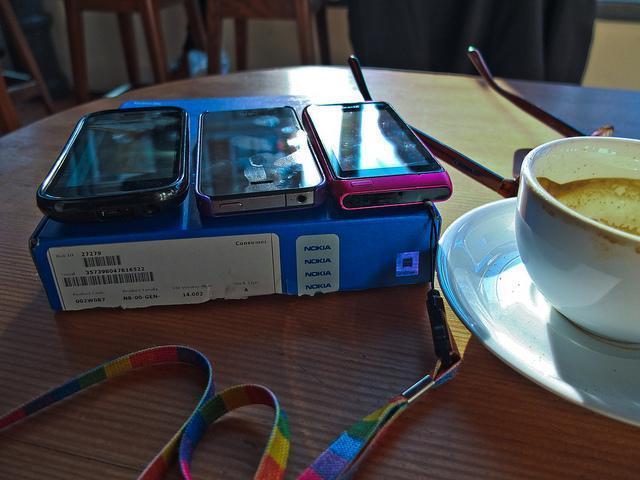How many cell phones are there?
Give a very brief answer. 3. How many chairs are visible?
Give a very brief answer. 3. 